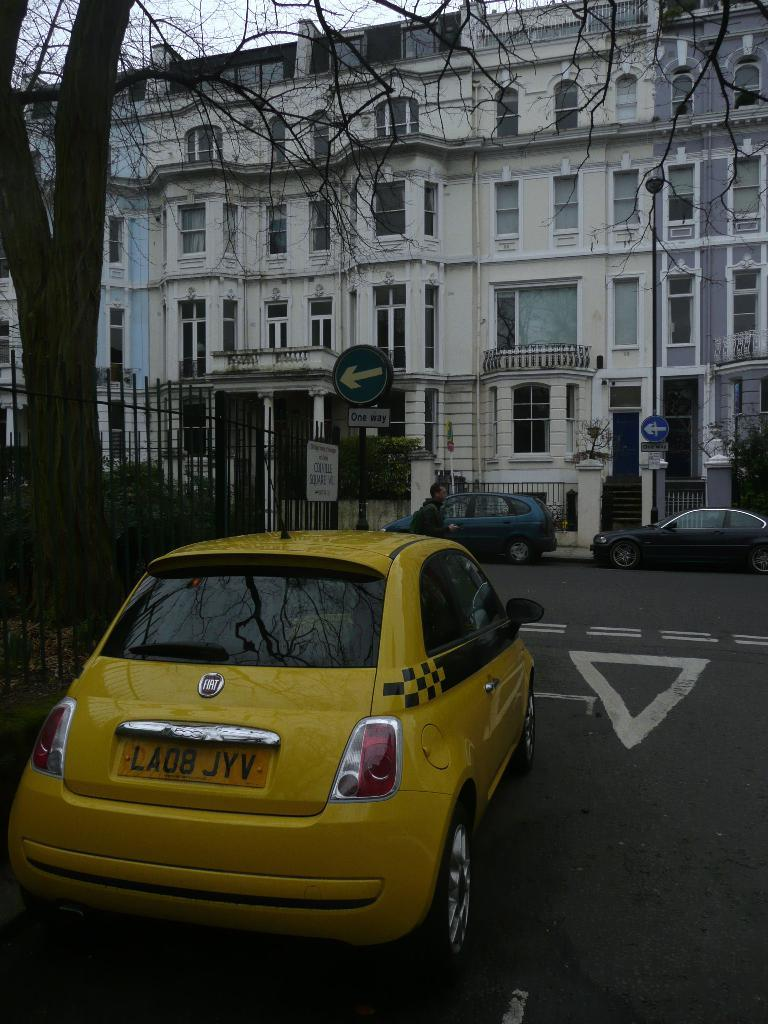<image>
Write a terse but informative summary of the picture. A taxi cab with the license plate LA08 JYV is parked in front of buildings. 